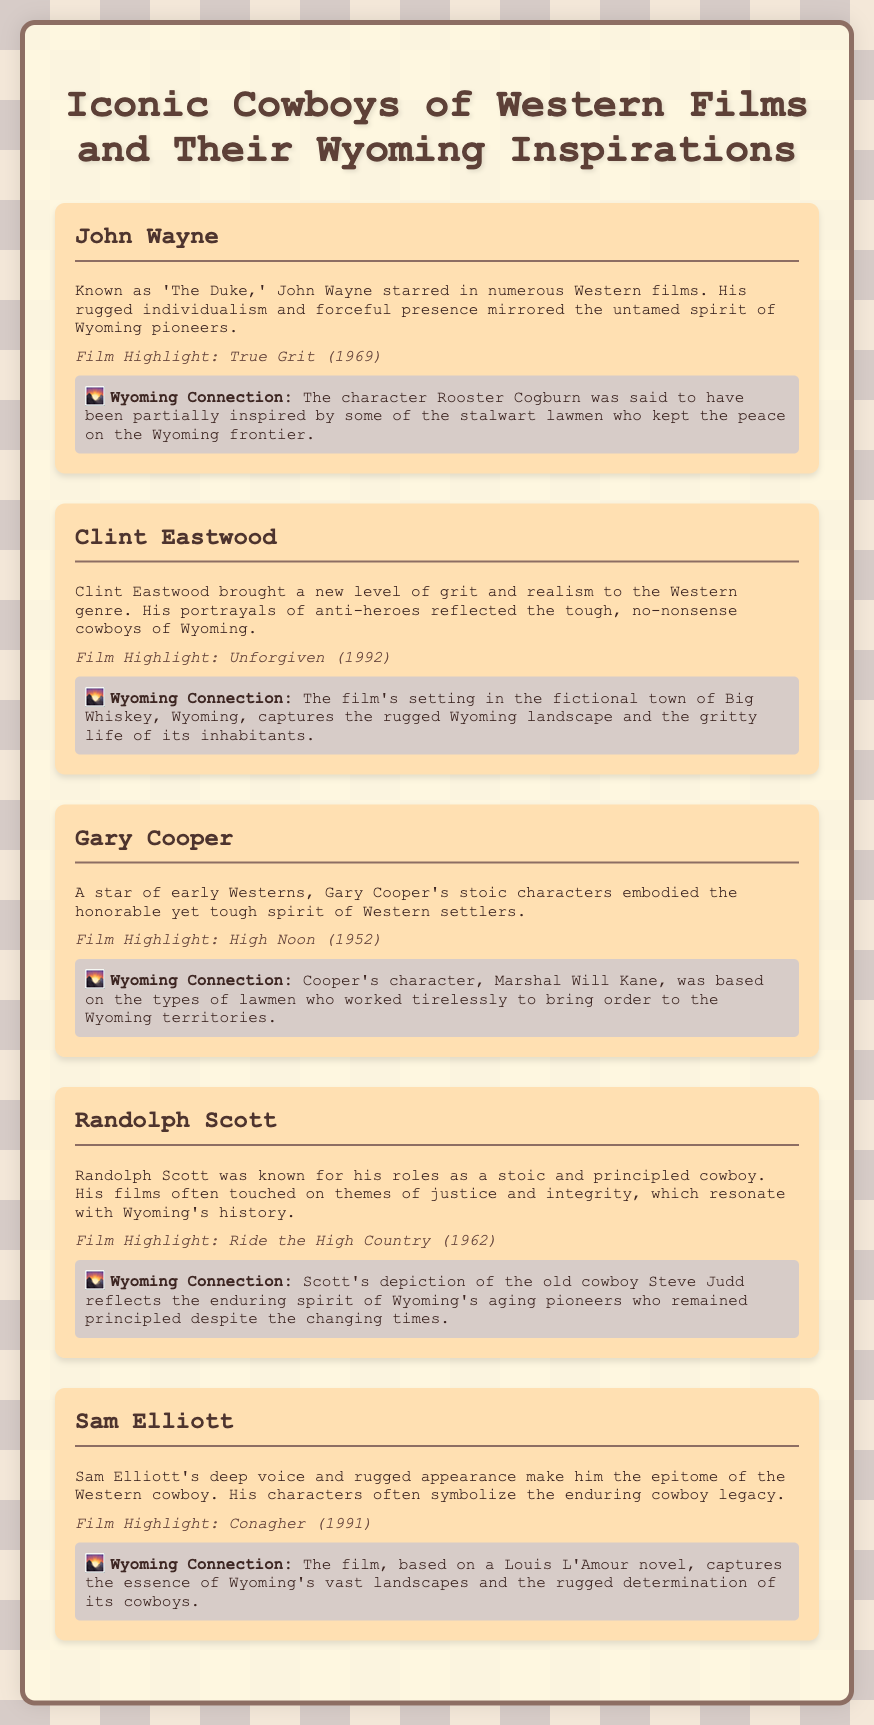What character did John Wayne portray in 'True Grit'? The document highlights that John Wayne starred in 'True Grit' (1969) as the character Rooster Cogburn.
Answer: Rooster Cogburn Which film did Clint Eastwood star in that is mentioned? Clint Eastwood's film highlighted in the document is 'Unforgiven' (1992).
Answer: Unforgiven What type of character does Sam Elliott often portray? The document states that Sam Elliott's characters often symbolize the enduring cowboy legacy.
Answer: Enduring cowboy legacy Who was inspired by Wyoming lawmen? John Wayne's character Rooster Cogburn is said to have been partially inspired by Wyoming lawmen.
Answer: John Wayne What is the common theme present in Randolph Scott's films? The document mentions that Randolph Scott's films often touch on themes of justice and integrity.
Answer: Justice and integrity In which year was 'High Noon' released? The document lists 'High Noon' (1952) as the film highlight for Gary Cooper.
Answer: 1952 What film captures the essence of Wyoming's landscapes according to the document? The document states that 'Conagher' captures the essence of Wyoming's vast landscapes.
Answer: Conagher Which actor is referred to as 'The Duke'? The document mentions that John Wayne is known as 'The Duke.'
Answer: John Wayne Which actor's character reflects Wyoming's aging pioneers? Randolph Scott's character in 'Ride the High Country' reflects Wyoming's aging pioneers.
Answer: Randolph Scott 